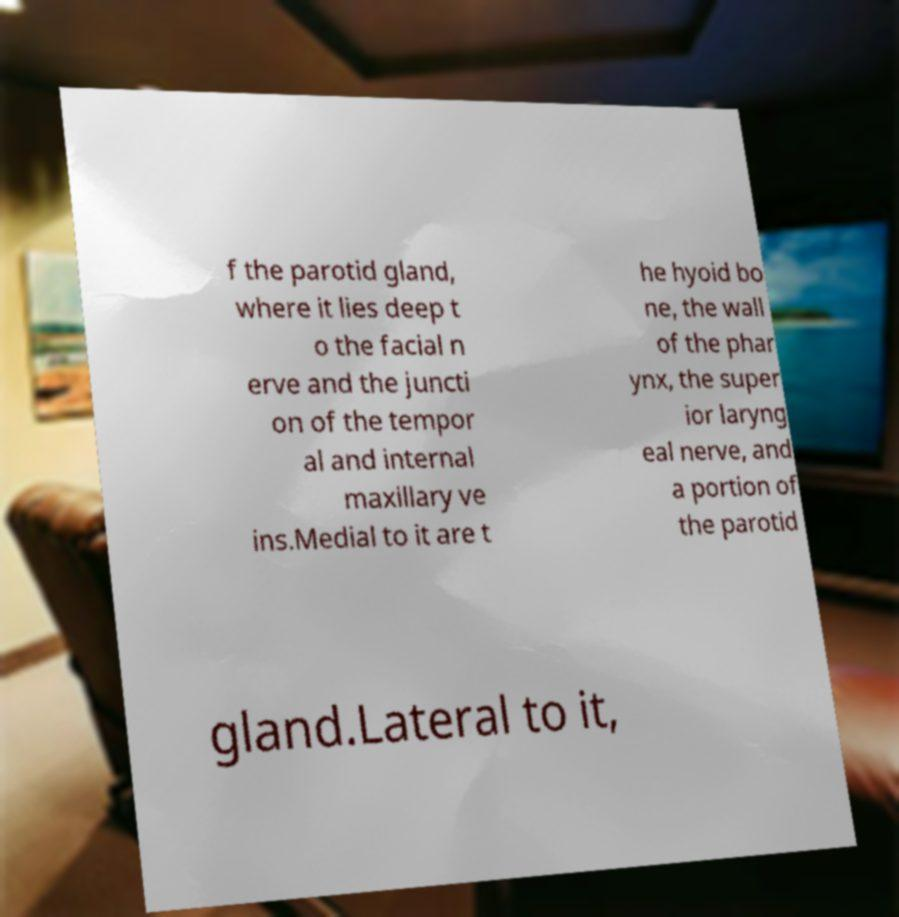What messages or text are displayed in this image? I need them in a readable, typed format. f the parotid gland, where it lies deep t o the facial n erve and the juncti on of the tempor al and internal maxillary ve ins.Medial to it are t he hyoid bo ne, the wall of the phar ynx, the super ior laryng eal nerve, and a portion of the parotid gland.Lateral to it, 